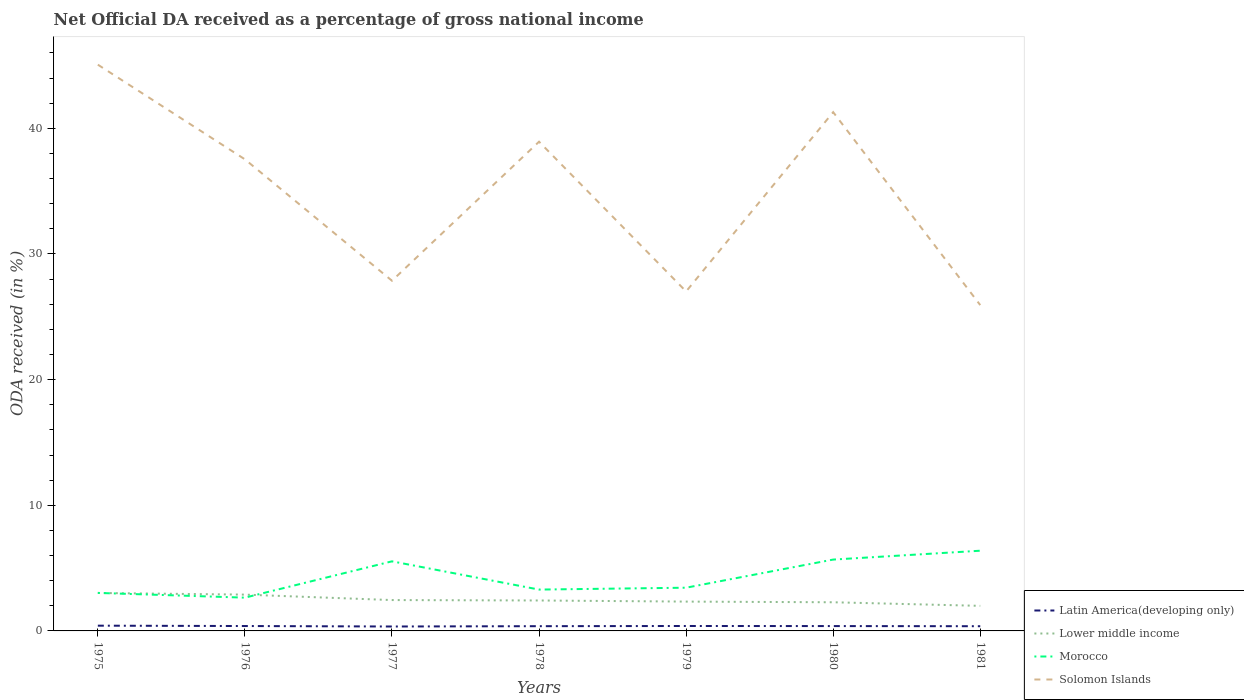Does the line corresponding to Solomon Islands intersect with the line corresponding to Lower middle income?
Provide a succinct answer. No. Across all years, what is the maximum net official DA received in Lower middle income?
Provide a succinct answer. 2. What is the total net official DA received in Latin America(developing only) in the graph?
Provide a succinct answer. 0.01. What is the difference between the highest and the second highest net official DA received in Solomon Islands?
Offer a very short reply. 19.14. What is the difference between the highest and the lowest net official DA received in Latin America(developing only)?
Your response must be concise. 4. How many lines are there?
Provide a succinct answer. 4. How many years are there in the graph?
Your answer should be very brief. 7. What is the difference between two consecutive major ticks on the Y-axis?
Offer a very short reply. 10. Are the values on the major ticks of Y-axis written in scientific E-notation?
Provide a short and direct response. No. Does the graph contain grids?
Keep it short and to the point. No. Where does the legend appear in the graph?
Keep it short and to the point. Bottom right. How are the legend labels stacked?
Offer a terse response. Vertical. What is the title of the graph?
Make the answer very short. Net Official DA received as a percentage of gross national income. Does "Euro area" appear as one of the legend labels in the graph?
Keep it short and to the point. No. What is the label or title of the X-axis?
Offer a terse response. Years. What is the label or title of the Y-axis?
Offer a terse response. ODA received (in %). What is the ODA received (in %) of Latin America(developing only) in 1975?
Make the answer very short. 0.42. What is the ODA received (in %) of Lower middle income in 1975?
Your answer should be very brief. 3.02. What is the ODA received (in %) in Morocco in 1975?
Your answer should be compact. 3.02. What is the ODA received (in %) in Solomon Islands in 1975?
Make the answer very short. 45.07. What is the ODA received (in %) of Latin America(developing only) in 1976?
Give a very brief answer. 0.39. What is the ODA received (in %) in Lower middle income in 1976?
Offer a very short reply. 2.89. What is the ODA received (in %) in Morocco in 1976?
Ensure brevity in your answer.  2.65. What is the ODA received (in %) of Solomon Islands in 1976?
Your response must be concise. 37.53. What is the ODA received (in %) in Latin America(developing only) in 1977?
Ensure brevity in your answer.  0.35. What is the ODA received (in %) in Lower middle income in 1977?
Provide a succinct answer. 2.46. What is the ODA received (in %) in Morocco in 1977?
Give a very brief answer. 5.54. What is the ODA received (in %) of Solomon Islands in 1977?
Give a very brief answer. 27.87. What is the ODA received (in %) of Latin America(developing only) in 1978?
Ensure brevity in your answer.  0.38. What is the ODA received (in %) in Lower middle income in 1978?
Give a very brief answer. 2.42. What is the ODA received (in %) in Morocco in 1978?
Your answer should be compact. 3.29. What is the ODA received (in %) of Solomon Islands in 1978?
Provide a succinct answer. 38.94. What is the ODA received (in %) of Latin America(developing only) in 1979?
Your answer should be very brief. 0.39. What is the ODA received (in %) of Lower middle income in 1979?
Provide a succinct answer. 2.33. What is the ODA received (in %) of Morocco in 1979?
Ensure brevity in your answer.  3.44. What is the ODA received (in %) of Solomon Islands in 1979?
Keep it short and to the point. 27.02. What is the ODA received (in %) of Latin America(developing only) in 1980?
Offer a very short reply. 0.39. What is the ODA received (in %) of Lower middle income in 1980?
Give a very brief answer. 2.28. What is the ODA received (in %) of Morocco in 1980?
Offer a terse response. 5.68. What is the ODA received (in %) of Solomon Islands in 1980?
Provide a short and direct response. 41.29. What is the ODA received (in %) of Latin America(developing only) in 1981?
Make the answer very short. 0.37. What is the ODA received (in %) in Lower middle income in 1981?
Provide a succinct answer. 2. What is the ODA received (in %) in Morocco in 1981?
Make the answer very short. 6.38. What is the ODA received (in %) of Solomon Islands in 1981?
Your answer should be very brief. 25.93. Across all years, what is the maximum ODA received (in %) of Latin America(developing only)?
Provide a short and direct response. 0.42. Across all years, what is the maximum ODA received (in %) of Lower middle income?
Make the answer very short. 3.02. Across all years, what is the maximum ODA received (in %) in Morocco?
Your response must be concise. 6.38. Across all years, what is the maximum ODA received (in %) of Solomon Islands?
Offer a terse response. 45.07. Across all years, what is the minimum ODA received (in %) in Latin America(developing only)?
Your answer should be very brief. 0.35. Across all years, what is the minimum ODA received (in %) of Lower middle income?
Make the answer very short. 2. Across all years, what is the minimum ODA received (in %) in Morocco?
Make the answer very short. 2.65. Across all years, what is the minimum ODA received (in %) in Solomon Islands?
Offer a very short reply. 25.93. What is the total ODA received (in %) of Latin America(developing only) in the graph?
Offer a terse response. 2.69. What is the total ODA received (in %) of Lower middle income in the graph?
Ensure brevity in your answer.  17.4. What is the total ODA received (in %) of Morocco in the graph?
Give a very brief answer. 30. What is the total ODA received (in %) of Solomon Islands in the graph?
Provide a short and direct response. 243.64. What is the difference between the ODA received (in %) in Latin America(developing only) in 1975 and that in 1976?
Keep it short and to the point. 0.03. What is the difference between the ODA received (in %) in Lower middle income in 1975 and that in 1976?
Offer a terse response. 0.13. What is the difference between the ODA received (in %) of Morocco in 1975 and that in 1976?
Your response must be concise. 0.38. What is the difference between the ODA received (in %) of Solomon Islands in 1975 and that in 1976?
Make the answer very short. 7.53. What is the difference between the ODA received (in %) in Latin America(developing only) in 1975 and that in 1977?
Give a very brief answer. 0.07. What is the difference between the ODA received (in %) of Lower middle income in 1975 and that in 1977?
Offer a terse response. 0.57. What is the difference between the ODA received (in %) in Morocco in 1975 and that in 1977?
Ensure brevity in your answer.  -2.51. What is the difference between the ODA received (in %) of Solomon Islands in 1975 and that in 1977?
Offer a very short reply. 17.2. What is the difference between the ODA received (in %) of Latin America(developing only) in 1975 and that in 1978?
Give a very brief answer. 0.04. What is the difference between the ODA received (in %) of Lower middle income in 1975 and that in 1978?
Your response must be concise. 0.6. What is the difference between the ODA received (in %) in Morocco in 1975 and that in 1978?
Ensure brevity in your answer.  -0.27. What is the difference between the ODA received (in %) of Solomon Islands in 1975 and that in 1978?
Give a very brief answer. 6.13. What is the difference between the ODA received (in %) of Latin America(developing only) in 1975 and that in 1979?
Offer a very short reply. 0.03. What is the difference between the ODA received (in %) of Lower middle income in 1975 and that in 1979?
Provide a short and direct response. 0.69. What is the difference between the ODA received (in %) in Morocco in 1975 and that in 1979?
Offer a very short reply. -0.41. What is the difference between the ODA received (in %) in Solomon Islands in 1975 and that in 1979?
Ensure brevity in your answer.  18.05. What is the difference between the ODA received (in %) of Latin America(developing only) in 1975 and that in 1980?
Make the answer very short. 0.03. What is the difference between the ODA received (in %) in Lower middle income in 1975 and that in 1980?
Offer a very short reply. 0.74. What is the difference between the ODA received (in %) in Morocco in 1975 and that in 1980?
Your answer should be very brief. -2.65. What is the difference between the ODA received (in %) of Solomon Islands in 1975 and that in 1980?
Ensure brevity in your answer.  3.78. What is the difference between the ODA received (in %) in Latin America(developing only) in 1975 and that in 1981?
Your answer should be compact. 0.04. What is the difference between the ODA received (in %) of Lower middle income in 1975 and that in 1981?
Your answer should be very brief. 1.03. What is the difference between the ODA received (in %) in Morocco in 1975 and that in 1981?
Give a very brief answer. -3.36. What is the difference between the ODA received (in %) of Solomon Islands in 1975 and that in 1981?
Offer a very short reply. 19.14. What is the difference between the ODA received (in %) of Latin America(developing only) in 1976 and that in 1977?
Make the answer very short. 0.04. What is the difference between the ODA received (in %) of Lower middle income in 1976 and that in 1977?
Offer a very short reply. 0.43. What is the difference between the ODA received (in %) of Morocco in 1976 and that in 1977?
Your response must be concise. -2.89. What is the difference between the ODA received (in %) of Solomon Islands in 1976 and that in 1977?
Ensure brevity in your answer.  9.66. What is the difference between the ODA received (in %) in Latin America(developing only) in 1976 and that in 1978?
Provide a short and direct response. 0.01. What is the difference between the ODA received (in %) in Lower middle income in 1976 and that in 1978?
Keep it short and to the point. 0.47. What is the difference between the ODA received (in %) in Morocco in 1976 and that in 1978?
Ensure brevity in your answer.  -0.64. What is the difference between the ODA received (in %) of Solomon Islands in 1976 and that in 1978?
Make the answer very short. -1.4. What is the difference between the ODA received (in %) in Latin America(developing only) in 1976 and that in 1979?
Offer a very short reply. -0. What is the difference between the ODA received (in %) of Lower middle income in 1976 and that in 1979?
Provide a short and direct response. 0.55. What is the difference between the ODA received (in %) of Morocco in 1976 and that in 1979?
Your answer should be compact. -0.79. What is the difference between the ODA received (in %) in Solomon Islands in 1976 and that in 1979?
Keep it short and to the point. 10.51. What is the difference between the ODA received (in %) of Latin America(developing only) in 1976 and that in 1980?
Provide a succinct answer. 0. What is the difference between the ODA received (in %) of Lower middle income in 1976 and that in 1980?
Your response must be concise. 0.61. What is the difference between the ODA received (in %) in Morocco in 1976 and that in 1980?
Offer a terse response. -3.03. What is the difference between the ODA received (in %) of Solomon Islands in 1976 and that in 1980?
Provide a short and direct response. -3.75. What is the difference between the ODA received (in %) in Latin America(developing only) in 1976 and that in 1981?
Your response must be concise. 0.02. What is the difference between the ODA received (in %) in Lower middle income in 1976 and that in 1981?
Keep it short and to the point. 0.89. What is the difference between the ODA received (in %) in Morocco in 1976 and that in 1981?
Your answer should be very brief. -3.73. What is the difference between the ODA received (in %) of Solomon Islands in 1976 and that in 1981?
Your answer should be very brief. 11.6. What is the difference between the ODA received (in %) in Latin America(developing only) in 1977 and that in 1978?
Your response must be concise. -0.03. What is the difference between the ODA received (in %) in Lower middle income in 1977 and that in 1978?
Your answer should be very brief. 0.03. What is the difference between the ODA received (in %) in Morocco in 1977 and that in 1978?
Provide a short and direct response. 2.25. What is the difference between the ODA received (in %) of Solomon Islands in 1977 and that in 1978?
Give a very brief answer. -11.06. What is the difference between the ODA received (in %) in Latin America(developing only) in 1977 and that in 1979?
Offer a terse response. -0.04. What is the difference between the ODA received (in %) of Lower middle income in 1977 and that in 1979?
Your response must be concise. 0.12. What is the difference between the ODA received (in %) of Morocco in 1977 and that in 1979?
Your answer should be very brief. 2.1. What is the difference between the ODA received (in %) in Solomon Islands in 1977 and that in 1979?
Give a very brief answer. 0.85. What is the difference between the ODA received (in %) of Latin America(developing only) in 1977 and that in 1980?
Your answer should be very brief. -0.03. What is the difference between the ODA received (in %) in Lower middle income in 1977 and that in 1980?
Provide a short and direct response. 0.18. What is the difference between the ODA received (in %) in Morocco in 1977 and that in 1980?
Provide a short and direct response. -0.14. What is the difference between the ODA received (in %) of Solomon Islands in 1977 and that in 1980?
Provide a succinct answer. -13.42. What is the difference between the ODA received (in %) in Latin America(developing only) in 1977 and that in 1981?
Offer a terse response. -0.02. What is the difference between the ODA received (in %) of Lower middle income in 1977 and that in 1981?
Ensure brevity in your answer.  0.46. What is the difference between the ODA received (in %) of Morocco in 1977 and that in 1981?
Your answer should be compact. -0.84. What is the difference between the ODA received (in %) of Solomon Islands in 1977 and that in 1981?
Provide a short and direct response. 1.94. What is the difference between the ODA received (in %) in Latin America(developing only) in 1978 and that in 1979?
Make the answer very short. -0.02. What is the difference between the ODA received (in %) of Lower middle income in 1978 and that in 1979?
Keep it short and to the point. 0.09. What is the difference between the ODA received (in %) of Morocco in 1978 and that in 1979?
Make the answer very short. -0.15. What is the difference between the ODA received (in %) of Solomon Islands in 1978 and that in 1979?
Provide a succinct answer. 11.92. What is the difference between the ODA received (in %) in Latin America(developing only) in 1978 and that in 1980?
Make the answer very short. -0.01. What is the difference between the ODA received (in %) of Lower middle income in 1978 and that in 1980?
Your answer should be very brief. 0.14. What is the difference between the ODA received (in %) in Morocco in 1978 and that in 1980?
Give a very brief answer. -2.39. What is the difference between the ODA received (in %) of Solomon Islands in 1978 and that in 1980?
Provide a succinct answer. -2.35. What is the difference between the ODA received (in %) of Latin America(developing only) in 1978 and that in 1981?
Your response must be concise. 0. What is the difference between the ODA received (in %) in Lower middle income in 1978 and that in 1981?
Your answer should be compact. 0.43. What is the difference between the ODA received (in %) in Morocco in 1978 and that in 1981?
Your response must be concise. -3.09. What is the difference between the ODA received (in %) in Solomon Islands in 1978 and that in 1981?
Offer a very short reply. 13. What is the difference between the ODA received (in %) of Latin America(developing only) in 1979 and that in 1980?
Your answer should be very brief. 0.01. What is the difference between the ODA received (in %) in Lower middle income in 1979 and that in 1980?
Your answer should be very brief. 0.05. What is the difference between the ODA received (in %) of Morocco in 1979 and that in 1980?
Offer a terse response. -2.24. What is the difference between the ODA received (in %) in Solomon Islands in 1979 and that in 1980?
Give a very brief answer. -14.27. What is the difference between the ODA received (in %) of Latin America(developing only) in 1979 and that in 1981?
Your response must be concise. 0.02. What is the difference between the ODA received (in %) in Lower middle income in 1979 and that in 1981?
Offer a terse response. 0.34. What is the difference between the ODA received (in %) in Morocco in 1979 and that in 1981?
Give a very brief answer. -2.94. What is the difference between the ODA received (in %) of Solomon Islands in 1979 and that in 1981?
Your answer should be compact. 1.09. What is the difference between the ODA received (in %) in Latin America(developing only) in 1980 and that in 1981?
Your answer should be very brief. 0.01. What is the difference between the ODA received (in %) of Lower middle income in 1980 and that in 1981?
Give a very brief answer. 0.29. What is the difference between the ODA received (in %) in Morocco in 1980 and that in 1981?
Provide a short and direct response. -0.7. What is the difference between the ODA received (in %) in Solomon Islands in 1980 and that in 1981?
Your answer should be compact. 15.36. What is the difference between the ODA received (in %) of Latin America(developing only) in 1975 and the ODA received (in %) of Lower middle income in 1976?
Keep it short and to the point. -2.47. What is the difference between the ODA received (in %) in Latin America(developing only) in 1975 and the ODA received (in %) in Morocco in 1976?
Keep it short and to the point. -2.23. What is the difference between the ODA received (in %) of Latin America(developing only) in 1975 and the ODA received (in %) of Solomon Islands in 1976?
Your answer should be compact. -37.11. What is the difference between the ODA received (in %) of Lower middle income in 1975 and the ODA received (in %) of Morocco in 1976?
Provide a short and direct response. 0.37. What is the difference between the ODA received (in %) of Lower middle income in 1975 and the ODA received (in %) of Solomon Islands in 1976?
Offer a terse response. -34.51. What is the difference between the ODA received (in %) of Morocco in 1975 and the ODA received (in %) of Solomon Islands in 1976?
Your answer should be very brief. -34.51. What is the difference between the ODA received (in %) of Latin America(developing only) in 1975 and the ODA received (in %) of Lower middle income in 1977?
Give a very brief answer. -2.04. What is the difference between the ODA received (in %) of Latin America(developing only) in 1975 and the ODA received (in %) of Morocco in 1977?
Give a very brief answer. -5.12. What is the difference between the ODA received (in %) in Latin America(developing only) in 1975 and the ODA received (in %) in Solomon Islands in 1977?
Keep it short and to the point. -27.45. What is the difference between the ODA received (in %) of Lower middle income in 1975 and the ODA received (in %) of Morocco in 1977?
Make the answer very short. -2.52. What is the difference between the ODA received (in %) in Lower middle income in 1975 and the ODA received (in %) in Solomon Islands in 1977?
Keep it short and to the point. -24.85. What is the difference between the ODA received (in %) of Morocco in 1975 and the ODA received (in %) of Solomon Islands in 1977?
Offer a terse response. -24.85. What is the difference between the ODA received (in %) in Latin America(developing only) in 1975 and the ODA received (in %) in Lower middle income in 1978?
Offer a terse response. -2. What is the difference between the ODA received (in %) of Latin America(developing only) in 1975 and the ODA received (in %) of Morocco in 1978?
Offer a very short reply. -2.87. What is the difference between the ODA received (in %) in Latin America(developing only) in 1975 and the ODA received (in %) in Solomon Islands in 1978?
Ensure brevity in your answer.  -38.52. What is the difference between the ODA received (in %) of Lower middle income in 1975 and the ODA received (in %) of Morocco in 1978?
Provide a short and direct response. -0.27. What is the difference between the ODA received (in %) in Lower middle income in 1975 and the ODA received (in %) in Solomon Islands in 1978?
Your answer should be very brief. -35.91. What is the difference between the ODA received (in %) of Morocco in 1975 and the ODA received (in %) of Solomon Islands in 1978?
Your answer should be compact. -35.91. What is the difference between the ODA received (in %) in Latin America(developing only) in 1975 and the ODA received (in %) in Lower middle income in 1979?
Your response must be concise. -1.92. What is the difference between the ODA received (in %) of Latin America(developing only) in 1975 and the ODA received (in %) of Morocco in 1979?
Provide a succinct answer. -3.02. What is the difference between the ODA received (in %) of Latin America(developing only) in 1975 and the ODA received (in %) of Solomon Islands in 1979?
Make the answer very short. -26.6. What is the difference between the ODA received (in %) in Lower middle income in 1975 and the ODA received (in %) in Morocco in 1979?
Provide a succinct answer. -0.42. What is the difference between the ODA received (in %) of Lower middle income in 1975 and the ODA received (in %) of Solomon Islands in 1979?
Provide a succinct answer. -24. What is the difference between the ODA received (in %) in Morocco in 1975 and the ODA received (in %) in Solomon Islands in 1979?
Your answer should be very brief. -23.99. What is the difference between the ODA received (in %) in Latin America(developing only) in 1975 and the ODA received (in %) in Lower middle income in 1980?
Offer a terse response. -1.86. What is the difference between the ODA received (in %) of Latin America(developing only) in 1975 and the ODA received (in %) of Morocco in 1980?
Keep it short and to the point. -5.26. What is the difference between the ODA received (in %) of Latin America(developing only) in 1975 and the ODA received (in %) of Solomon Islands in 1980?
Ensure brevity in your answer.  -40.87. What is the difference between the ODA received (in %) in Lower middle income in 1975 and the ODA received (in %) in Morocco in 1980?
Make the answer very short. -2.66. What is the difference between the ODA received (in %) of Lower middle income in 1975 and the ODA received (in %) of Solomon Islands in 1980?
Provide a succinct answer. -38.27. What is the difference between the ODA received (in %) in Morocco in 1975 and the ODA received (in %) in Solomon Islands in 1980?
Your answer should be compact. -38.26. What is the difference between the ODA received (in %) in Latin America(developing only) in 1975 and the ODA received (in %) in Lower middle income in 1981?
Give a very brief answer. -1.58. What is the difference between the ODA received (in %) in Latin America(developing only) in 1975 and the ODA received (in %) in Morocco in 1981?
Offer a very short reply. -5.96. What is the difference between the ODA received (in %) in Latin America(developing only) in 1975 and the ODA received (in %) in Solomon Islands in 1981?
Keep it short and to the point. -25.51. What is the difference between the ODA received (in %) of Lower middle income in 1975 and the ODA received (in %) of Morocco in 1981?
Your answer should be very brief. -3.36. What is the difference between the ODA received (in %) of Lower middle income in 1975 and the ODA received (in %) of Solomon Islands in 1981?
Your answer should be very brief. -22.91. What is the difference between the ODA received (in %) of Morocco in 1975 and the ODA received (in %) of Solomon Islands in 1981?
Offer a very short reply. -22.91. What is the difference between the ODA received (in %) of Latin America(developing only) in 1976 and the ODA received (in %) of Lower middle income in 1977?
Make the answer very short. -2.07. What is the difference between the ODA received (in %) of Latin America(developing only) in 1976 and the ODA received (in %) of Morocco in 1977?
Make the answer very short. -5.15. What is the difference between the ODA received (in %) of Latin America(developing only) in 1976 and the ODA received (in %) of Solomon Islands in 1977?
Make the answer very short. -27.48. What is the difference between the ODA received (in %) of Lower middle income in 1976 and the ODA received (in %) of Morocco in 1977?
Your answer should be very brief. -2.65. What is the difference between the ODA received (in %) in Lower middle income in 1976 and the ODA received (in %) in Solomon Islands in 1977?
Your answer should be compact. -24.98. What is the difference between the ODA received (in %) in Morocco in 1976 and the ODA received (in %) in Solomon Islands in 1977?
Offer a very short reply. -25.22. What is the difference between the ODA received (in %) of Latin America(developing only) in 1976 and the ODA received (in %) of Lower middle income in 1978?
Keep it short and to the point. -2.03. What is the difference between the ODA received (in %) of Latin America(developing only) in 1976 and the ODA received (in %) of Morocco in 1978?
Your answer should be compact. -2.9. What is the difference between the ODA received (in %) of Latin America(developing only) in 1976 and the ODA received (in %) of Solomon Islands in 1978?
Give a very brief answer. -38.55. What is the difference between the ODA received (in %) in Lower middle income in 1976 and the ODA received (in %) in Morocco in 1978?
Keep it short and to the point. -0.4. What is the difference between the ODA received (in %) in Lower middle income in 1976 and the ODA received (in %) in Solomon Islands in 1978?
Give a very brief answer. -36.05. What is the difference between the ODA received (in %) in Morocco in 1976 and the ODA received (in %) in Solomon Islands in 1978?
Your answer should be compact. -36.29. What is the difference between the ODA received (in %) of Latin America(developing only) in 1976 and the ODA received (in %) of Lower middle income in 1979?
Provide a succinct answer. -1.94. What is the difference between the ODA received (in %) of Latin America(developing only) in 1976 and the ODA received (in %) of Morocco in 1979?
Your answer should be compact. -3.05. What is the difference between the ODA received (in %) of Latin America(developing only) in 1976 and the ODA received (in %) of Solomon Islands in 1979?
Keep it short and to the point. -26.63. What is the difference between the ODA received (in %) of Lower middle income in 1976 and the ODA received (in %) of Morocco in 1979?
Offer a terse response. -0.55. What is the difference between the ODA received (in %) of Lower middle income in 1976 and the ODA received (in %) of Solomon Islands in 1979?
Provide a short and direct response. -24.13. What is the difference between the ODA received (in %) of Morocco in 1976 and the ODA received (in %) of Solomon Islands in 1979?
Provide a succinct answer. -24.37. What is the difference between the ODA received (in %) of Latin America(developing only) in 1976 and the ODA received (in %) of Lower middle income in 1980?
Offer a terse response. -1.89. What is the difference between the ODA received (in %) in Latin America(developing only) in 1976 and the ODA received (in %) in Morocco in 1980?
Provide a short and direct response. -5.29. What is the difference between the ODA received (in %) of Latin America(developing only) in 1976 and the ODA received (in %) of Solomon Islands in 1980?
Provide a succinct answer. -40.9. What is the difference between the ODA received (in %) of Lower middle income in 1976 and the ODA received (in %) of Morocco in 1980?
Offer a terse response. -2.79. What is the difference between the ODA received (in %) of Lower middle income in 1976 and the ODA received (in %) of Solomon Islands in 1980?
Your answer should be very brief. -38.4. What is the difference between the ODA received (in %) of Morocco in 1976 and the ODA received (in %) of Solomon Islands in 1980?
Offer a terse response. -38.64. What is the difference between the ODA received (in %) in Latin America(developing only) in 1976 and the ODA received (in %) in Lower middle income in 1981?
Ensure brevity in your answer.  -1.61. What is the difference between the ODA received (in %) of Latin America(developing only) in 1976 and the ODA received (in %) of Morocco in 1981?
Keep it short and to the point. -5.99. What is the difference between the ODA received (in %) in Latin America(developing only) in 1976 and the ODA received (in %) in Solomon Islands in 1981?
Provide a short and direct response. -25.54. What is the difference between the ODA received (in %) in Lower middle income in 1976 and the ODA received (in %) in Morocco in 1981?
Offer a terse response. -3.49. What is the difference between the ODA received (in %) in Lower middle income in 1976 and the ODA received (in %) in Solomon Islands in 1981?
Ensure brevity in your answer.  -23.04. What is the difference between the ODA received (in %) of Morocco in 1976 and the ODA received (in %) of Solomon Islands in 1981?
Your answer should be compact. -23.28. What is the difference between the ODA received (in %) of Latin America(developing only) in 1977 and the ODA received (in %) of Lower middle income in 1978?
Give a very brief answer. -2.07. What is the difference between the ODA received (in %) in Latin America(developing only) in 1977 and the ODA received (in %) in Morocco in 1978?
Provide a short and direct response. -2.94. What is the difference between the ODA received (in %) in Latin America(developing only) in 1977 and the ODA received (in %) in Solomon Islands in 1978?
Your answer should be very brief. -38.58. What is the difference between the ODA received (in %) in Lower middle income in 1977 and the ODA received (in %) in Morocco in 1978?
Give a very brief answer. -0.83. What is the difference between the ODA received (in %) in Lower middle income in 1977 and the ODA received (in %) in Solomon Islands in 1978?
Your answer should be very brief. -36.48. What is the difference between the ODA received (in %) in Morocco in 1977 and the ODA received (in %) in Solomon Islands in 1978?
Give a very brief answer. -33.4. What is the difference between the ODA received (in %) in Latin America(developing only) in 1977 and the ODA received (in %) in Lower middle income in 1979?
Make the answer very short. -1.98. What is the difference between the ODA received (in %) of Latin America(developing only) in 1977 and the ODA received (in %) of Morocco in 1979?
Keep it short and to the point. -3.09. What is the difference between the ODA received (in %) of Latin America(developing only) in 1977 and the ODA received (in %) of Solomon Islands in 1979?
Your answer should be very brief. -26.67. What is the difference between the ODA received (in %) in Lower middle income in 1977 and the ODA received (in %) in Morocco in 1979?
Your answer should be very brief. -0.98. What is the difference between the ODA received (in %) of Lower middle income in 1977 and the ODA received (in %) of Solomon Islands in 1979?
Your answer should be compact. -24.56. What is the difference between the ODA received (in %) of Morocco in 1977 and the ODA received (in %) of Solomon Islands in 1979?
Your answer should be very brief. -21.48. What is the difference between the ODA received (in %) of Latin America(developing only) in 1977 and the ODA received (in %) of Lower middle income in 1980?
Ensure brevity in your answer.  -1.93. What is the difference between the ODA received (in %) of Latin America(developing only) in 1977 and the ODA received (in %) of Morocco in 1980?
Your answer should be very brief. -5.33. What is the difference between the ODA received (in %) in Latin America(developing only) in 1977 and the ODA received (in %) in Solomon Islands in 1980?
Your answer should be compact. -40.93. What is the difference between the ODA received (in %) of Lower middle income in 1977 and the ODA received (in %) of Morocco in 1980?
Make the answer very short. -3.22. What is the difference between the ODA received (in %) in Lower middle income in 1977 and the ODA received (in %) in Solomon Islands in 1980?
Keep it short and to the point. -38.83. What is the difference between the ODA received (in %) in Morocco in 1977 and the ODA received (in %) in Solomon Islands in 1980?
Offer a very short reply. -35.75. What is the difference between the ODA received (in %) of Latin America(developing only) in 1977 and the ODA received (in %) of Lower middle income in 1981?
Your answer should be very brief. -1.64. What is the difference between the ODA received (in %) in Latin America(developing only) in 1977 and the ODA received (in %) in Morocco in 1981?
Your response must be concise. -6.03. What is the difference between the ODA received (in %) in Latin America(developing only) in 1977 and the ODA received (in %) in Solomon Islands in 1981?
Give a very brief answer. -25.58. What is the difference between the ODA received (in %) of Lower middle income in 1977 and the ODA received (in %) of Morocco in 1981?
Ensure brevity in your answer.  -3.93. What is the difference between the ODA received (in %) in Lower middle income in 1977 and the ODA received (in %) in Solomon Islands in 1981?
Provide a short and direct response. -23.48. What is the difference between the ODA received (in %) of Morocco in 1977 and the ODA received (in %) of Solomon Islands in 1981?
Your answer should be compact. -20.39. What is the difference between the ODA received (in %) in Latin America(developing only) in 1978 and the ODA received (in %) in Lower middle income in 1979?
Offer a terse response. -1.96. What is the difference between the ODA received (in %) of Latin America(developing only) in 1978 and the ODA received (in %) of Morocco in 1979?
Your answer should be compact. -3.06. What is the difference between the ODA received (in %) in Latin America(developing only) in 1978 and the ODA received (in %) in Solomon Islands in 1979?
Your answer should be very brief. -26.64. What is the difference between the ODA received (in %) in Lower middle income in 1978 and the ODA received (in %) in Morocco in 1979?
Offer a very short reply. -1.02. What is the difference between the ODA received (in %) of Lower middle income in 1978 and the ODA received (in %) of Solomon Islands in 1979?
Your answer should be compact. -24.6. What is the difference between the ODA received (in %) of Morocco in 1978 and the ODA received (in %) of Solomon Islands in 1979?
Provide a short and direct response. -23.73. What is the difference between the ODA received (in %) of Latin America(developing only) in 1978 and the ODA received (in %) of Lower middle income in 1980?
Give a very brief answer. -1.9. What is the difference between the ODA received (in %) in Latin America(developing only) in 1978 and the ODA received (in %) in Morocco in 1980?
Ensure brevity in your answer.  -5.3. What is the difference between the ODA received (in %) of Latin America(developing only) in 1978 and the ODA received (in %) of Solomon Islands in 1980?
Your answer should be compact. -40.91. What is the difference between the ODA received (in %) of Lower middle income in 1978 and the ODA received (in %) of Morocco in 1980?
Make the answer very short. -3.26. What is the difference between the ODA received (in %) of Lower middle income in 1978 and the ODA received (in %) of Solomon Islands in 1980?
Offer a very short reply. -38.86. What is the difference between the ODA received (in %) in Morocco in 1978 and the ODA received (in %) in Solomon Islands in 1980?
Ensure brevity in your answer.  -38. What is the difference between the ODA received (in %) of Latin America(developing only) in 1978 and the ODA received (in %) of Lower middle income in 1981?
Offer a terse response. -1.62. What is the difference between the ODA received (in %) in Latin America(developing only) in 1978 and the ODA received (in %) in Morocco in 1981?
Your response must be concise. -6.01. What is the difference between the ODA received (in %) in Latin America(developing only) in 1978 and the ODA received (in %) in Solomon Islands in 1981?
Your response must be concise. -25.55. What is the difference between the ODA received (in %) in Lower middle income in 1978 and the ODA received (in %) in Morocco in 1981?
Provide a short and direct response. -3.96. What is the difference between the ODA received (in %) of Lower middle income in 1978 and the ODA received (in %) of Solomon Islands in 1981?
Offer a very short reply. -23.51. What is the difference between the ODA received (in %) in Morocco in 1978 and the ODA received (in %) in Solomon Islands in 1981?
Your answer should be compact. -22.64. What is the difference between the ODA received (in %) in Latin America(developing only) in 1979 and the ODA received (in %) in Lower middle income in 1980?
Provide a short and direct response. -1.89. What is the difference between the ODA received (in %) in Latin America(developing only) in 1979 and the ODA received (in %) in Morocco in 1980?
Your answer should be compact. -5.29. What is the difference between the ODA received (in %) of Latin America(developing only) in 1979 and the ODA received (in %) of Solomon Islands in 1980?
Keep it short and to the point. -40.89. What is the difference between the ODA received (in %) in Lower middle income in 1979 and the ODA received (in %) in Morocco in 1980?
Offer a terse response. -3.34. What is the difference between the ODA received (in %) in Lower middle income in 1979 and the ODA received (in %) in Solomon Islands in 1980?
Ensure brevity in your answer.  -38.95. What is the difference between the ODA received (in %) in Morocco in 1979 and the ODA received (in %) in Solomon Islands in 1980?
Provide a short and direct response. -37.85. What is the difference between the ODA received (in %) in Latin America(developing only) in 1979 and the ODA received (in %) in Lower middle income in 1981?
Keep it short and to the point. -1.6. What is the difference between the ODA received (in %) of Latin America(developing only) in 1979 and the ODA received (in %) of Morocco in 1981?
Your answer should be compact. -5.99. What is the difference between the ODA received (in %) of Latin America(developing only) in 1979 and the ODA received (in %) of Solomon Islands in 1981?
Ensure brevity in your answer.  -25.54. What is the difference between the ODA received (in %) in Lower middle income in 1979 and the ODA received (in %) in Morocco in 1981?
Your answer should be very brief. -4.05. What is the difference between the ODA received (in %) in Lower middle income in 1979 and the ODA received (in %) in Solomon Islands in 1981?
Ensure brevity in your answer.  -23.6. What is the difference between the ODA received (in %) of Morocco in 1979 and the ODA received (in %) of Solomon Islands in 1981?
Offer a terse response. -22.49. What is the difference between the ODA received (in %) of Latin America(developing only) in 1980 and the ODA received (in %) of Lower middle income in 1981?
Your answer should be compact. -1.61. What is the difference between the ODA received (in %) in Latin America(developing only) in 1980 and the ODA received (in %) in Morocco in 1981?
Provide a short and direct response. -6. What is the difference between the ODA received (in %) of Latin America(developing only) in 1980 and the ODA received (in %) of Solomon Islands in 1981?
Your answer should be compact. -25.55. What is the difference between the ODA received (in %) of Lower middle income in 1980 and the ODA received (in %) of Morocco in 1981?
Make the answer very short. -4.1. What is the difference between the ODA received (in %) in Lower middle income in 1980 and the ODA received (in %) in Solomon Islands in 1981?
Give a very brief answer. -23.65. What is the difference between the ODA received (in %) of Morocco in 1980 and the ODA received (in %) of Solomon Islands in 1981?
Keep it short and to the point. -20.25. What is the average ODA received (in %) in Latin America(developing only) per year?
Ensure brevity in your answer.  0.38. What is the average ODA received (in %) of Lower middle income per year?
Offer a terse response. 2.49. What is the average ODA received (in %) of Morocco per year?
Your answer should be compact. 4.29. What is the average ODA received (in %) in Solomon Islands per year?
Your answer should be very brief. 34.81. In the year 1975, what is the difference between the ODA received (in %) of Latin America(developing only) and ODA received (in %) of Lower middle income?
Your answer should be compact. -2.6. In the year 1975, what is the difference between the ODA received (in %) of Latin America(developing only) and ODA received (in %) of Morocco?
Offer a very short reply. -2.61. In the year 1975, what is the difference between the ODA received (in %) in Latin America(developing only) and ODA received (in %) in Solomon Islands?
Your answer should be compact. -44.65. In the year 1975, what is the difference between the ODA received (in %) of Lower middle income and ODA received (in %) of Morocco?
Offer a very short reply. -0. In the year 1975, what is the difference between the ODA received (in %) of Lower middle income and ODA received (in %) of Solomon Islands?
Provide a succinct answer. -42.05. In the year 1975, what is the difference between the ODA received (in %) in Morocco and ODA received (in %) in Solomon Islands?
Keep it short and to the point. -42.04. In the year 1976, what is the difference between the ODA received (in %) in Latin America(developing only) and ODA received (in %) in Lower middle income?
Offer a terse response. -2.5. In the year 1976, what is the difference between the ODA received (in %) in Latin America(developing only) and ODA received (in %) in Morocco?
Make the answer very short. -2.26. In the year 1976, what is the difference between the ODA received (in %) in Latin America(developing only) and ODA received (in %) in Solomon Islands?
Your answer should be very brief. -37.14. In the year 1976, what is the difference between the ODA received (in %) of Lower middle income and ODA received (in %) of Morocco?
Offer a very short reply. 0.24. In the year 1976, what is the difference between the ODA received (in %) of Lower middle income and ODA received (in %) of Solomon Islands?
Offer a terse response. -34.64. In the year 1976, what is the difference between the ODA received (in %) in Morocco and ODA received (in %) in Solomon Islands?
Provide a succinct answer. -34.88. In the year 1977, what is the difference between the ODA received (in %) in Latin America(developing only) and ODA received (in %) in Lower middle income?
Offer a very short reply. -2.1. In the year 1977, what is the difference between the ODA received (in %) in Latin America(developing only) and ODA received (in %) in Morocco?
Give a very brief answer. -5.19. In the year 1977, what is the difference between the ODA received (in %) in Latin America(developing only) and ODA received (in %) in Solomon Islands?
Keep it short and to the point. -27.52. In the year 1977, what is the difference between the ODA received (in %) in Lower middle income and ODA received (in %) in Morocco?
Your response must be concise. -3.08. In the year 1977, what is the difference between the ODA received (in %) of Lower middle income and ODA received (in %) of Solomon Islands?
Provide a succinct answer. -25.41. In the year 1977, what is the difference between the ODA received (in %) in Morocco and ODA received (in %) in Solomon Islands?
Keep it short and to the point. -22.33. In the year 1978, what is the difference between the ODA received (in %) of Latin America(developing only) and ODA received (in %) of Lower middle income?
Ensure brevity in your answer.  -2.05. In the year 1978, what is the difference between the ODA received (in %) in Latin America(developing only) and ODA received (in %) in Morocco?
Ensure brevity in your answer.  -2.91. In the year 1978, what is the difference between the ODA received (in %) in Latin America(developing only) and ODA received (in %) in Solomon Islands?
Ensure brevity in your answer.  -38.56. In the year 1978, what is the difference between the ODA received (in %) of Lower middle income and ODA received (in %) of Morocco?
Offer a terse response. -0.87. In the year 1978, what is the difference between the ODA received (in %) of Lower middle income and ODA received (in %) of Solomon Islands?
Offer a very short reply. -36.51. In the year 1978, what is the difference between the ODA received (in %) of Morocco and ODA received (in %) of Solomon Islands?
Your response must be concise. -35.65. In the year 1979, what is the difference between the ODA received (in %) in Latin America(developing only) and ODA received (in %) in Lower middle income?
Give a very brief answer. -1.94. In the year 1979, what is the difference between the ODA received (in %) of Latin America(developing only) and ODA received (in %) of Morocco?
Give a very brief answer. -3.05. In the year 1979, what is the difference between the ODA received (in %) of Latin America(developing only) and ODA received (in %) of Solomon Islands?
Provide a succinct answer. -26.63. In the year 1979, what is the difference between the ODA received (in %) of Lower middle income and ODA received (in %) of Morocco?
Make the answer very short. -1.11. In the year 1979, what is the difference between the ODA received (in %) in Lower middle income and ODA received (in %) in Solomon Islands?
Provide a succinct answer. -24.68. In the year 1979, what is the difference between the ODA received (in %) in Morocco and ODA received (in %) in Solomon Islands?
Give a very brief answer. -23.58. In the year 1980, what is the difference between the ODA received (in %) of Latin America(developing only) and ODA received (in %) of Lower middle income?
Offer a terse response. -1.89. In the year 1980, what is the difference between the ODA received (in %) of Latin America(developing only) and ODA received (in %) of Morocco?
Your answer should be very brief. -5.29. In the year 1980, what is the difference between the ODA received (in %) in Latin America(developing only) and ODA received (in %) in Solomon Islands?
Your answer should be very brief. -40.9. In the year 1980, what is the difference between the ODA received (in %) in Lower middle income and ODA received (in %) in Morocco?
Your answer should be compact. -3.4. In the year 1980, what is the difference between the ODA received (in %) in Lower middle income and ODA received (in %) in Solomon Islands?
Keep it short and to the point. -39.01. In the year 1980, what is the difference between the ODA received (in %) in Morocco and ODA received (in %) in Solomon Islands?
Provide a short and direct response. -35.61. In the year 1981, what is the difference between the ODA received (in %) in Latin America(developing only) and ODA received (in %) in Lower middle income?
Keep it short and to the point. -1.62. In the year 1981, what is the difference between the ODA received (in %) of Latin America(developing only) and ODA received (in %) of Morocco?
Your answer should be very brief. -6.01. In the year 1981, what is the difference between the ODA received (in %) in Latin America(developing only) and ODA received (in %) in Solomon Islands?
Make the answer very short. -25.56. In the year 1981, what is the difference between the ODA received (in %) in Lower middle income and ODA received (in %) in Morocco?
Offer a terse response. -4.39. In the year 1981, what is the difference between the ODA received (in %) in Lower middle income and ODA received (in %) in Solomon Islands?
Keep it short and to the point. -23.94. In the year 1981, what is the difference between the ODA received (in %) of Morocco and ODA received (in %) of Solomon Islands?
Make the answer very short. -19.55. What is the ratio of the ODA received (in %) in Latin America(developing only) in 1975 to that in 1976?
Your answer should be compact. 1.07. What is the ratio of the ODA received (in %) in Lower middle income in 1975 to that in 1976?
Provide a short and direct response. 1.05. What is the ratio of the ODA received (in %) of Morocco in 1975 to that in 1976?
Your answer should be very brief. 1.14. What is the ratio of the ODA received (in %) in Solomon Islands in 1975 to that in 1976?
Ensure brevity in your answer.  1.2. What is the ratio of the ODA received (in %) of Latin America(developing only) in 1975 to that in 1977?
Your response must be concise. 1.19. What is the ratio of the ODA received (in %) of Lower middle income in 1975 to that in 1977?
Give a very brief answer. 1.23. What is the ratio of the ODA received (in %) in Morocco in 1975 to that in 1977?
Provide a succinct answer. 0.55. What is the ratio of the ODA received (in %) of Solomon Islands in 1975 to that in 1977?
Make the answer very short. 1.62. What is the ratio of the ODA received (in %) of Latin America(developing only) in 1975 to that in 1978?
Your response must be concise. 1.11. What is the ratio of the ODA received (in %) of Lower middle income in 1975 to that in 1978?
Keep it short and to the point. 1.25. What is the ratio of the ODA received (in %) in Morocco in 1975 to that in 1978?
Provide a short and direct response. 0.92. What is the ratio of the ODA received (in %) of Solomon Islands in 1975 to that in 1978?
Your answer should be very brief. 1.16. What is the ratio of the ODA received (in %) of Latin America(developing only) in 1975 to that in 1979?
Your answer should be compact. 1.07. What is the ratio of the ODA received (in %) in Lower middle income in 1975 to that in 1979?
Offer a terse response. 1.29. What is the ratio of the ODA received (in %) of Morocco in 1975 to that in 1979?
Ensure brevity in your answer.  0.88. What is the ratio of the ODA received (in %) of Solomon Islands in 1975 to that in 1979?
Ensure brevity in your answer.  1.67. What is the ratio of the ODA received (in %) in Latin America(developing only) in 1975 to that in 1980?
Ensure brevity in your answer.  1.08. What is the ratio of the ODA received (in %) of Lower middle income in 1975 to that in 1980?
Offer a terse response. 1.32. What is the ratio of the ODA received (in %) of Morocco in 1975 to that in 1980?
Give a very brief answer. 0.53. What is the ratio of the ODA received (in %) in Solomon Islands in 1975 to that in 1980?
Offer a terse response. 1.09. What is the ratio of the ODA received (in %) in Latin America(developing only) in 1975 to that in 1981?
Provide a short and direct response. 1.12. What is the ratio of the ODA received (in %) in Lower middle income in 1975 to that in 1981?
Make the answer very short. 1.51. What is the ratio of the ODA received (in %) of Morocco in 1975 to that in 1981?
Your answer should be very brief. 0.47. What is the ratio of the ODA received (in %) of Solomon Islands in 1975 to that in 1981?
Keep it short and to the point. 1.74. What is the ratio of the ODA received (in %) in Latin America(developing only) in 1976 to that in 1977?
Offer a very short reply. 1.11. What is the ratio of the ODA received (in %) of Lower middle income in 1976 to that in 1977?
Provide a succinct answer. 1.18. What is the ratio of the ODA received (in %) of Morocco in 1976 to that in 1977?
Offer a terse response. 0.48. What is the ratio of the ODA received (in %) of Solomon Islands in 1976 to that in 1977?
Provide a short and direct response. 1.35. What is the ratio of the ODA received (in %) in Latin America(developing only) in 1976 to that in 1978?
Make the answer very short. 1.03. What is the ratio of the ODA received (in %) in Lower middle income in 1976 to that in 1978?
Offer a terse response. 1.19. What is the ratio of the ODA received (in %) in Morocco in 1976 to that in 1978?
Ensure brevity in your answer.  0.8. What is the ratio of the ODA received (in %) of Solomon Islands in 1976 to that in 1978?
Your answer should be compact. 0.96. What is the ratio of the ODA received (in %) of Lower middle income in 1976 to that in 1979?
Offer a terse response. 1.24. What is the ratio of the ODA received (in %) in Morocco in 1976 to that in 1979?
Your response must be concise. 0.77. What is the ratio of the ODA received (in %) in Solomon Islands in 1976 to that in 1979?
Offer a terse response. 1.39. What is the ratio of the ODA received (in %) in Latin America(developing only) in 1976 to that in 1980?
Your answer should be very brief. 1.01. What is the ratio of the ODA received (in %) of Lower middle income in 1976 to that in 1980?
Your answer should be very brief. 1.27. What is the ratio of the ODA received (in %) in Morocco in 1976 to that in 1980?
Offer a very short reply. 0.47. What is the ratio of the ODA received (in %) in Solomon Islands in 1976 to that in 1980?
Provide a succinct answer. 0.91. What is the ratio of the ODA received (in %) of Latin America(developing only) in 1976 to that in 1981?
Ensure brevity in your answer.  1.04. What is the ratio of the ODA received (in %) of Lower middle income in 1976 to that in 1981?
Provide a succinct answer. 1.45. What is the ratio of the ODA received (in %) of Morocco in 1976 to that in 1981?
Your answer should be compact. 0.41. What is the ratio of the ODA received (in %) in Solomon Islands in 1976 to that in 1981?
Provide a succinct answer. 1.45. What is the ratio of the ODA received (in %) in Latin America(developing only) in 1977 to that in 1978?
Give a very brief answer. 0.93. What is the ratio of the ODA received (in %) in Lower middle income in 1977 to that in 1978?
Keep it short and to the point. 1.01. What is the ratio of the ODA received (in %) of Morocco in 1977 to that in 1978?
Provide a short and direct response. 1.68. What is the ratio of the ODA received (in %) in Solomon Islands in 1977 to that in 1978?
Your answer should be very brief. 0.72. What is the ratio of the ODA received (in %) in Latin America(developing only) in 1977 to that in 1979?
Your answer should be very brief. 0.9. What is the ratio of the ODA received (in %) of Lower middle income in 1977 to that in 1979?
Make the answer very short. 1.05. What is the ratio of the ODA received (in %) of Morocco in 1977 to that in 1979?
Provide a short and direct response. 1.61. What is the ratio of the ODA received (in %) of Solomon Islands in 1977 to that in 1979?
Your answer should be very brief. 1.03. What is the ratio of the ODA received (in %) of Latin America(developing only) in 1977 to that in 1980?
Your answer should be compact. 0.91. What is the ratio of the ODA received (in %) in Lower middle income in 1977 to that in 1980?
Your answer should be compact. 1.08. What is the ratio of the ODA received (in %) of Morocco in 1977 to that in 1980?
Your answer should be very brief. 0.98. What is the ratio of the ODA received (in %) in Solomon Islands in 1977 to that in 1980?
Offer a very short reply. 0.68. What is the ratio of the ODA received (in %) of Latin America(developing only) in 1977 to that in 1981?
Your response must be concise. 0.94. What is the ratio of the ODA received (in %) of Lower middle income in 1977 to that in 1981?
Provide a succinct answer. 1.23. What is the ratio of the ODA received (in %) in Morocco in 1977 to that in 1981?
Your answer should be very brief. 0.87. What is the ratio of the ODA received (in %) in Solomon Islands in 1977 to that in 1981?
Make the answer very short. 1.07. What is the ratio of the ODA received (in %) of Latin America(developing only) in 1978 to that in 1979?
Make the answer very short. 0.96. What is the ratio of the ODA received (in %) of Lower middle income in 1978 to that in 1979?
Provide a short and direct response. 1.04. What is the ratio of the ODA received (in %) in Morocco in 1978 to that in 1979?
Offer a very short reply. 0.96. What is the ratio of the ODA received (in %) of Solomon Islands in 1978 to that in 1979?
Keep it short and to the point. 1.44. What is the ratio of the ODA received (in %) in Latin America(developing only) in 1978 to that in 1980?
Offer a very short reply. 0.98. What is the ratio of the ODA received (in %) of Lower middle income in 1978 to that in 1980?
Provide a succinct answer. 1.06. What is the ratio of the ODA received (in %) in Morocco in 1978 to that in 1980?
Give a very brief answer. 0.58. What is the ratio of the ODA received (in %) in Solomon Islands in 1978 to that in 1980?
Ensure brevity in your answer.  0.94. What is the ratio of the ODA received (in %) in Latin America(developing only) in 1978 to that in 1981?
Offer a terse response. 1.01. What is the ratio of the ODA received (in %) in Lower middle income in 1978 to that in 1981?
Ensure brevity in your answer.  1.21. What is the ratio of the ODA received (in %) in Morocco in 1978 to that in 1981?
Provide a succinct answer. 0.52. What is the ratio of the ODA received (in %) of Solomon Islands in 1978 to that in 1981?
Offer a very short reply. 1.5. What is the ratio of the ODA received (in %) in Latin America(developing only) in 1979 to that in 1980?
Provide a succinct answer. 1.02. What is the ratio of the ODA received (in %) of Lower middle income in 1979 to that in 1980?
Offer a terse response. 1.02. What is the ratio of the ODA received (in %) of Morocco in 1979 to that in 1980?
Give a very brief answer. 0.61. What is the ratio of the ODA received (in %) of Solomon Islands in 1979 to that in 1980?
Offer a terse response. 0.65. What is the ratio of the ODA received (in %) of Latin America(developing only) in 1979 to that in 1981?
Keep it short and to the point. 1.05. What is the ratio of the ODA received (in %) of Lower middle income in 1979 to that in 1981?
Your response must be concise. 1.17. What is the ratio of the ODA received (in %) of Morocco in 1979 to that in 1981?
Offer a terse response. 0.54. What is the ratio of the ODA received (in %) of Solomon Islands in 1979 to that in 1981?
Provide a short and direct response. 1.04. What is the ratio of the ODA received (in %) of Latin America(developing only) in 1980 to that in 1981?
Your answer should be compact. 1.03. What is the ratio of the ODA received (in %) of Lower middle income in 1980 to that in 1981?
Your answer should be very brief. 1.14. What is the ratio of the ODA received (in %) of Morocco in 1980 to that in 1981?
Offer a terse response. 0.89. What is the ratio of the ODA received (in %) of Solomon Islands in 1980 to that in 1981?
Ensure brevity in your answer.  1.59. What is the difference between the highest and the second highest ODA received (in %) in Latin America(developing only)?
Your answer should be compact. 0.03. What is the difference between the highest and the second highest ODA received (in %) in Lower middle income?
Offer a terse response. 0.13. What is the difference between the highest and the second highest ODA received (in %) of Morocco?
Ensure brevity in your answer.  0.7. What is the difference between the highest and the second highest ODA received (in %) of Solomon Islands?
Offer a terse response. 3.78. What is the difference between the highest and the lowest ODA received (in %) of Latin America(developing only)?
Offer a very short reply. 0.07. What is the difference between the highest and the lowest ODA received (in %) of Lower middle income?
Give a very brief answer. 1.03. What is the difference between the highest and the lowest ODA received (in %) in Morocco?
Your answer should be very brief. 3.73. What is the difference between the highest and the lowest ODA received (in %) of Solomon Islands?
Provide a succinct answer. 19.14. 